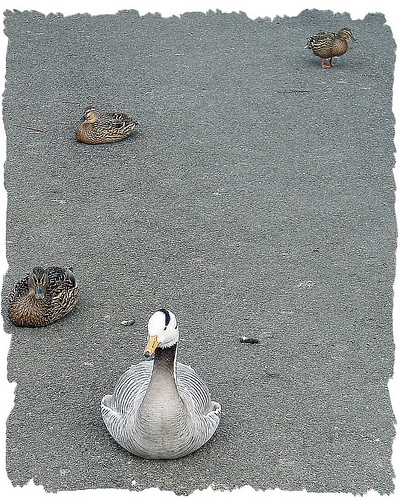<image>
Is there a bird on the road? Yes. Looking at the image, I can see the bird is positioned on top of the road, with the road providing support. 